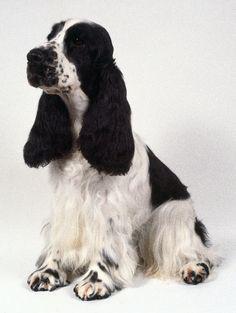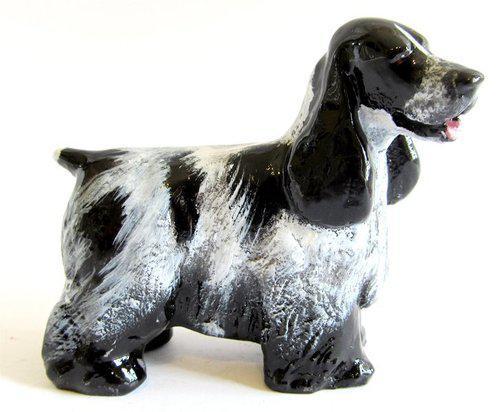The first image is the image on the left, the second image is the image on the right. Considering the images on both sides, is "Left image features one dog sitting with head and body turned leftward." valid? Answer yes or no. Yes. The first image is the image on the left, the second image is the image on the right. Considering the images on both sides, is "One dog is not in a sitting position." valid? Answer yes or no. Yes. 